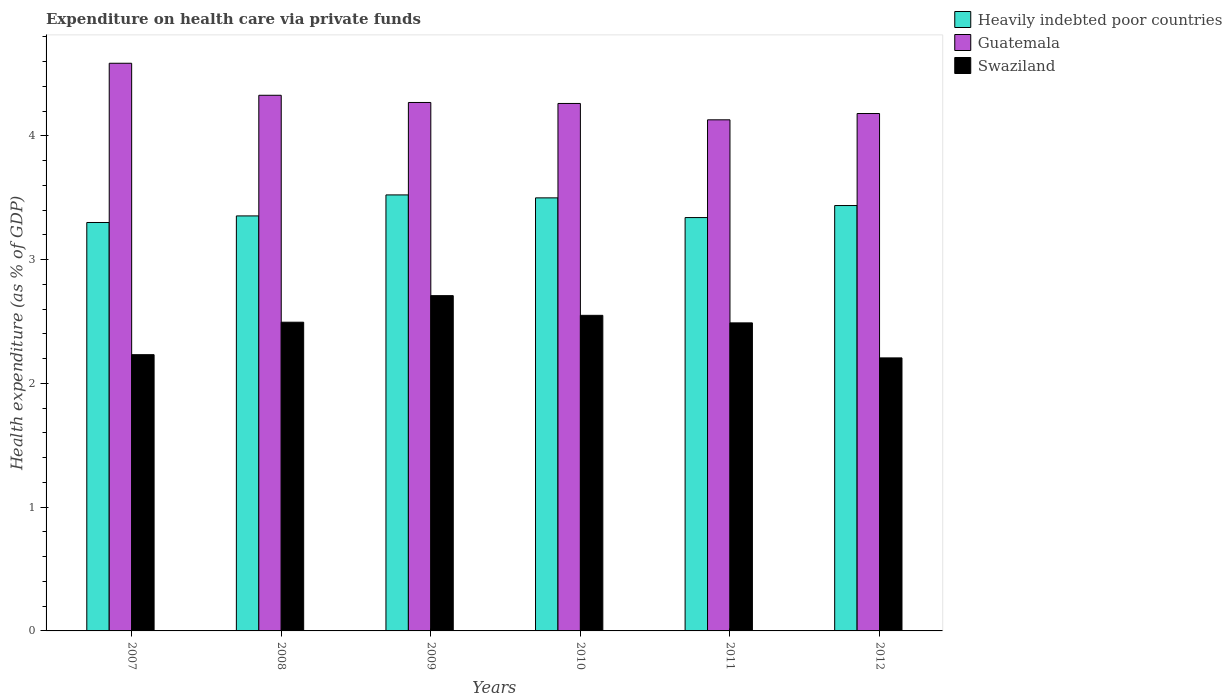How many different coloured bars are there?
Your response must be concise. 3. Are the number of bars per tick equal to the number of legend labels?
Ensure brevity in your answer.  Yes. Are the number of bars on each tick of the X-axis equal?
Provide a succinct answer. Yes. How many bars are there on the 4th tick from the left?
Your response must be concise. 3. In how many cases, is the number of bars for a given year not equal to the number of legend labels?
Make the answer very short. 0. What is the expenditure made on health care in Heavily indebted poor countries in 2008?
Offer a terse response. 3.35. Across all years, what is the maximum expenditure made on health care in Heavily indebted poor countries?
Make the answer very short. 3.52. Across all years, what is the minimum expenditure made on health care in Swaziland?
Give a very brief answer. 2.21. What is the total expenditure made on health care in Heavily indebted poor countries in the graph?
Offer a very short reply. 20.46. What is the difference between the expenditure made on health care in Guatemala in 2008 and that in 2010?
Give a very brief answer. 0.07. What is the difference between the expenditure made on health care in Guatemala in 2011 and the expenditure made on health care in Heavily indebted poor countries in 2008?
Provide a short and direct response. 0.78. What is the average expenditure made on health care in Guatemala per year?
Keep it short and to the point. 4.29. In the year 2007, what is the difference between the expenditure made on health care in Swaziland and expenditure made on health care in Heavily indebted poor countries?
Ensure brevity in your answer.  -1.07. In how many years, is the expenditure made on health care in Swaziland greater than 2.8 %?
Your answer should be compact. 0. What is the ratio of the expenditure made on health care in Swaziland in 2011 to that in 2012?
Your answer should be compact. 1.13. Is the difference between the expenditure made on health care in Swaziland in 2008 and 2011 greater than the difference between the expenditure made on health care in Heavily indebted poor countries in 2008 and 2011?
Ensure brevity in your answer.  No. What is the difference between the highest and the second highest expenditure made on health care in Guatemala?
Provide a short and direct response. 0.26. What is the difference between the highest and the lowest expenditure made on health care in Swaziland?
Your answer should be compact. 0.5. Is the sum of the expenditure made on health care in Swaziland in 2008 and 2010 greater than the maximum expenditure made on health care in Heavily indebted poor countries across all years?
Provide a succinct answer. Yes. What does the 1st bar from the left in 2010 represents?
Offer a very short reply. Heavily indebted poor countries. What does the 2nd bar from the right in 2008 represents?
Your answer should be compact. Guatemala. Is it the case that in every year, the sum of the expenditure made on health care in Heavily indebted poor countries and expenditure made on health care in Guatemala is greater than the expenditure made on health care in Swaziland?
Keep it short and to the point. Yes. How many bars are there?
Keep it short and to the point. 18. Are all the bars in the graph horizontal?
Your response must be concise. No. What is the difference between two consecutive major ticks on the Y-axis?
Keep it short and to the point. 1. Are the values on the major ticks of Y-axis written in scientific E-notation?
Ensure brevity in your answer.  No. Does the graph contain any zero values?
Make the answer very short. No. How many legend labels are there?
Provide a short and direct response. 3. How are the legend labels stacked?
Offer a terse response. Vertical. What is the title of the graph?
Offer a very short reply. Expenditure on health care via private funds. What is the label or title of the Y-axis?
Ensure brevity in your answer.  Health expenditure (as % of GDP). What is the Health expenditure (as % of GDP) of Heavily indebted poor countries in 2007?
Offer a terse response. 3.3. What is the Health expenditure (as % of GDP) of Guatemala in 2007?
Ensure brevity in your answer.  4.59. What is the Health expenditure (as % of GDP) in Swaziland in 2007?
Your answer should be compact. 2.23. What is the Health expenditure (as % of GDP) in Heavily indebted poor countries in 2008?
Offer a very short reply. 3.35. What is the Health expenditure (as % of GDP) in Guatemala in 2008?
Provide a succinct answer. 4.33. What is the Health expenditure (as % of GDP) of Swaziland in 2008?
Provide a short and direct response. 2.49. What is the Health expenditure (as % of GDP) of Heavily indebted poor countries in 2009?
Give a very brief answer. 3.52. What is the Health expenditure (as % of GDP) of Guatemala in 2009?
Your answer should be very brief. 4.27. What is the Health expenditure (as % of GDP) in Swaziland in 2009?
Provide a short and direct response. 2.71. What is the Health expenditure (as % of GDP) of Heavily indebted poor countries in 2010?
Offer a terse response. 3.5. What is the Health expenditure (as % of GDP) in Guatemala in 2010?
Offer a very short reply. 4.26. What is the Health expenditure (as % of GDP) of Swaziland in 2010?
Give a very brief answer. 2.55. What is the Health expenditure (as % of GDP) of Heavily indebted poor countries in 2011?
Your answer should be compact. 3.34. What is the Health expenditure (as % of GDP) of Guatemala in 2011?
Your answer should be compact. 4.13. What is the Health expenditure (as % of GDP) of Swaziland in 2011?
Make the answer very short. 2.49. What is the Health expenditure (as % of GDP) of Heavily indebted poor countries in 2012?
Provide a succinct answer. 3.44. What is the Health expenditure (as % of GDP) in Guatemala in 2012?
Offer a very short reply. 4.18. What is the Health expenditure (as % of GDP) of Swaziland in 2012?
Offer a very short reply. 2.21. Across all years, what is the maximum Health expenditure (as % of GDP) of Heavily indebted poor countries?
Offer a very short reply. 3.52. Across all years, what is the maximum Health expenditure (as % of GDP) in Guatemala?
Ensure brevity in your answer.  4.59. Across all years, what is the maximum Health expenditure (as % of GDP) in Swaziland?
Your answer should be very brief. 2.71. Across all years, what is the minimum Health expenditure (as % of GDP) of Heavily indebted poor countries?
Your answer should be compact. 3.3. Across all years, what is the minimum Health expenditure (as % of GDP) in Guatemala?
Provide a succinct answer. 4.13. Across all years, what is the minimum Health expenditure (as % of GDP) of Swaziland?
Give a very brief answer. 2.21. What is the total Health expenditure (as % of GDP) in Heavily indebted poor countries in the graph?
Offer a very short reply. 20.46. What is the total Health expenditure (as % of GDP) in Guatemala in the graph?
Provide a succinct answer. 25.76. What is the total Health expenditure (as % of GDP) of Swaziland in the graph?
Provide a short and direct response. 14.68. What is the difference between the Health expenditure (as % of GDP) of Heavily indebted poor countries in 2007 and that in 2008?
Offer a terse response. -0.05. What is the difference between the Health expenditure (as % of GDP) of Guatemala in 2007 and that in 2008?
Give a very brief answer. 0.26. What is the difference between the Health expenditure (as % of GDP) of Swaziland in 2007 and that in 2008?
Give a very brief answer. -0.26. What is the difference between the Health expenditure (as % of GDP) in Heavily indebted poor countries in 2007 and that in 2009?
Provide a short and direct response. -0.22. What is the difference between the Health expenditure (as % of GDP) of Guatemala in 2007 and that in 2009?
Your answer should be compact. 0.32. What is the difference between the Health expenditure (as % of GDP) of Swaziland in 2007 and that in 2009?
Provide a succinct answer. -0.48. What is the difference between the Health expenditure (as % of GDP) in Heavily indebted poor countries in 2007 and that in 2010?
Your response must be concise. -0.2. What is the difference between the Health expenditure (as % of GDP) of Guatemala in 2007 and that in 2010?
Ensure brevity in your answer.  0.32. What is the difference between the Health expenditure (as % of GDP) of Swaziland in 2007 and that in 2010?
Make the answer very short. -0.32. What is the difference between the Health expenditure (as % of GDP) of Heavily indebted poor countries in 2007 and that in 2011?
Provide a succinct answer. -0.04. What is the difference between the Health expenditure (as % of GDP) of Guatemala in 2007 and that in 2011?
Give a very brief answer. 0.46. What is the difference between the Health expenditure (as % of GDP) of Swaziland in 2007 and that in 2011?
Ensure brevity in your answer.  -0.26. What is the difference between the Health expenditure (as % of GDP) of Heavily indebted poor countries in 2007 and that in 2012?
Ensure brevity in your answer.  -0.14. What is the difference between the Health expenditure (as % of GDP) in Guatemala in 2007 and that in 2012?
Ensure brevity in your answer.  0.41. What is the difference between the Health expenditure (as % of GDP) of Swaziland in 2007 and that in 2012?
Give a very brief answer. 0.03. What is the difference between the Health expenditure (as % of GDP) of Heavily indebted poor countries in 2008 and that in 2009?
Ensure brevity in your answer.  -0.17. What is the difference between the Health expenditure (as % of GDP) in Guatemala in 2008 and that in 2009?
Provide a short and direct response. 0.06. What is the difference between the Health expenditure (as % of GDP) in Swaziland in 2008 and that in 2009?
Provide a short and direct response. -0.21. What is the difference between the Health expenditure (as % of GDP) in Heavily indebted poor countries in 2008 and that in 2010?
Provide a short and direct response. -0.15. What is the difference between the Health expenditure (as % of GDP) of Guatemala in 2008 and that in 2010?
Ensure brevity in your answer.  0.07. What is the difference between the Health expenditure (as % of GDP) in Swaziland in 2008 and that in 2010?
Give a very brief answer. -0.06. What is the difference between the Health expenditure (as % of GDP) of Heavily indebted poor countries in 2008 and that in 2011?
Give a very brief answer. 0.01. What is the difference between the Health expenditure (as % of GDP) of Guatemala in 2008 and that in 2011?
Offer a terse response. 0.2. What is the difference between the Health expenditure (as % of GDP) of Swaziland in 2008 and that in 2011?
Your answer should be very brief. 0.01. What is the difference between the Health expenditure (as % of GDP) in Heavily indebted poor countries in 2008 and that in 2012?
Give a very brief answer. -0.08. What is the difference between the Health expenditure (as % of GDP) of Guatemala in 2008 and that in 2012?
Give a very brief answer. 0.15. What is the difference between the Health expenditure (as % of GDP) in Swaziland in 2008 and that in 2012?
Your answer should be compact. 0.29. What is the difference between the Health expenditure (as % of GDP) of Heavily indebted poor countries in 2009 and that in 2010?
Your answer should be compact. 0.02. What is the difference between the Health expenditure (as % of GDP) of Guatemala in 2009 and that in 2010?
Provide a succinct answer. 0.01. What is the difference between the Health expenditure (as % of GDP) in Swaziland in 2009 and that in 2010?
Offer a very short reply. 0.16. What is the difference between the Health expenditure (as % of GDP) in Heavily indebted poor countries in 2009 and that in 2011?
Make the answer very short. 0.18. What is the difference between the Health expenditure (as % of GDP) in Guatemala in 2009 and that in 2011?
Keep it short and to the point. 0.14. What is the difference between the Health expenditure (as % of GDP) in Swaziland in 2009 and that in 2011?
Your answer should be very brief. 0.22. What is the difference between the Health expenditure (as % of GDP) in Heavily indebted poor countries in 2009 and that in 2012?
Keep it short and to the point. 0.09. What is the difference between the Health expenditure (as % of GDP) in Guatemala in 2009 and that in 2012?
Provide a short and direct response. 0.09. What is the difference between the Health expenditure (as % of GDP) in Swaziland in 2009 and that in 2012?
Your answer should be compact. 0.5. What is the difference between the Health expenditure (as % of GDP) of Heavily indebted poor countries in 2010 and that in 2011?
Ensure brevity in your answer.  0.16. What is the difference between the Health expenditure (as % of GDP) in Guatemala in 2010 and that in 2011?
Make the answer very short. 0.13. What is the difference between the Health expenditure (as % of GDP) in Swaziland in 2010 and that in 2011?
Your answer should be compact. 0.06. What is the difference between the Health expenditure (as % of GDP) in Heavily indebted poor countries in 2010 and that in 2012?
Ensure brevity in your answer.  0.06. What is the difference between the Health expenditure (as % of GDP) in Guatemala in 2010 and that in 2012?
Give a very brief answer. 0.08. What is the difference between the Health expenditure (as % of GDP) in Swaziland in 2010 and that in 2012?
Give a very brief answer. 0.34. What is the difference between the Health expenditure (as % of GDP) of Heavily indebted poor countries in 2011 and that in 2012?
Your answer should be compact. -0.1. What is the difference between the Health expenditure (as % of GDP) of Guatemala in 2011 and that in 2012?
Offer a very short reply. -0.05. What is the difference between the Health expenditure (as % of GDP) in Swaziland in 2011 and that in 2012?
Your answer should be compact. 0.28. What is the difference between the Health expenditure (as % of GDP) of Heavily indebted poor countries in 2007 and the Health expenditure (as % of GDP) of Guatemala in 2008?
Give a very brief answer. -1.03. What is the difference between the Health expenditure (as % of GDP) in Heavily indebted poor countries in 2007 and the Health expenditure (as % of GDP) in Swaziland in 2008?
Offer a terse response. 0.81. What is the difference between the Health expenditure (as % of GDP) in Guatemala in 2007 and the Health expenditure (as % of GDP) in Swaziland in 2008?
Your answer should be compact. 2.09. What is the difference between the Health expenditure (as % of GDP) in Heavily indebted poor countries in 2007 and the Health expenditure (as % of GDP) in Guatemala in 2009?
Your answer should be very brief. -0.97. What is the difference between the Health expenditure (as % of GDP) of Heavily indebted poor countries in 2007 and the Health expenditure (as % of GDP) of Swaziland in 2009?
Provide a short and direct response. 0.59. What is the difference between the Health expenditure (as % of GDP) in Guatemala in 2007 and the Health expenditure (as % of GDP) in Swaziland in 2009?
Give a very brief answer. 1.88. What is the difference between the Health expenditure (as % of GDP) in Heavily indebted poor countries in 2007 and the Health expenditure (as % of GDP) in Guatemala in 2010?
Your answer should be compact. -0.96. What is the difference between the Health expenditure (as % of GDP) in Heavily indebted poor countries in 2007 and the Health expenditure (as % of GDP) in Swaziland in 2010?
Offer a terse response. 0.75. What is the difference between the Health expenditure (as % of GDP) in Guatemala in 2007 and the Health expenditure (as % of GDP) in Swaziland in 2010?
Provide a succinct answer. 2.04. What is the difference between the Health expenditure (as % of GDP) in Heavily indebted poor countries in 2007 and the Health expenditure (as % of GDP) in Guatemala in 2011?
Provide a succinct answer. -0.83. What is the difference between the Health expenditure (as % of GDP) in Heavily indebted poor countries in 2007 and the Health expenditure (as % of GDP) in Swaziland in 2011?
Ensure brevity in your answer.  0.81. What is the difference between the Health expenditure (as % of GDP) of Guatemala in 2007 and the Health expenditure (as % of GDP) of Swaziland in 2011?
Your response must be concise. 2.1. What is the difference between the Health expenditure (as % of GDP) in Heavily indebted poor countries in 2007 and the Health expenditure (as % of GDP) in Guatemala in 2012?
Offer a very short reply. -0.88. What is the difference between the Health expenditure (as % of GDP) of Heavily indebted poor countries in 2007 and the Health expenditure (as % of GDP) of Swaziland in 2012?
Offer a terse response. 1.09. What is the difference between the Health expenditure (as % of GDP) in Guatemala in 2007 and the Health expenditure (as % of GDP) in Swaziland in 2012?
Provide a short and direct response. 2.38. What is the difference between the Health expenditure (as % of GDP) in Heavily indebted poor countries in 2008 and the Health expenditure (as % of GDP) in Guatemala in 2009?
Keep it short and to the point. -0.92. What is the difference between the Health expenditure (as % of GDP) of Heavily indebted poor countries in 2008 and the Health expenditure (as % of GDP) of Swaziland in 2009?
Your answer should be compact. 0.64. What is the difference between the Health expenditure (as % of GDP) of Guatemala in 2008 and the Health expenditure (as % of GDP) of Swaziland in 2009?
Make the answer very short. 1.62. What is the difference between the Health expenditure (as % of GDP) of Heavily indebted poor countries in 2008 and the Health expenditure (as % of GDP) of Guatemala in 2010?
Provide a short and direct response. -0.91. What is the difference between the Health expenditure (as % of GDP) in Heavily indebted poor countries in 2008 and the Health expenditure (as % of GDP) in Swaziland in 2010?
Your answer should be compact. 0.8. What is the difference between the Health expenditure (as % of GDP) in Guatemala in 2008 and the Health expenditure (as % of GDP) in Swaziland in 2010?
Provide a short and direct response. 1.78. What is the difference between the Health expenditure (as % of GDP) in Heavily indebted poor countries in 2008 and the Health expenditure (as % of GDP) in Guatemala in 2011?
Ensure brevity in your answer.  -0.78. What is the difference between the Health expenditure (as % of GDP) of Heavily indebted poor countries in 2008 and the Health expenditure (as % of GDP) of Swaziland in 2011?
Your response must be concise. 0.86. What is the difference between the Health expenditure (as % of GDP) in Guatemala in 2008 and the Health expenditure (as % of GDP) in Swaziland in 2011?
Provide a short and direct response. 1.84. What is the difference between the Health expenditure (as % of GDP) of Heavily indebted poor countries in 2008 and the Health expenditure (as % of GDP) of Guatemala in 2012?
Provide a succinct answer. -0.83. What is the difference between the Health expenditure (as % of GDP) of Heavily indebted poor countries in 2008 and the Health expenditure (as % of GDP) of Swaziland in 2012?
Provide a succinct answer. 1.15. What is the difference between the Health expenditure (as % of GDP) of Guatemala in 2008 and the Health expenditure (as % of GDP) of Swaziland in 2012?
Your response must be concise. 2.12. What is the difference between the Health expenditure (as % of GDP) in Heavily indebted poor countries in 2009 and the Health expenditure (as % of GDP) in Guatemala in 2010?
Offer a very short reply. -0.74. What is the difference between the Health expenditure (as % of GDP) in Heavily indebted poor countries in 2009 and the Health expenditure (as % of GDP) in Swaziland in 2010?
Offer a very short reply. 0.97. What is the difference between the Health expenditure (as % of GDP) of Guatemala in 2009 and the Health expenditure (as % of GDP) of Swaziland in 2010?
Provide a short and direct response. 1.72. What is the difference between the Health expenditure (as % of GDP) of Heavily indebted poor countries in 2009 and the Health expenditure (as % of GDP) of Guatemala in 2011?
Your response must be concise. -0.61. What is the difference between the Health expenditure (as % of GDP) in Heavily indebted poor countries in 2009 and the Health expenditure (as % of GDP) in Swaziland in 2011?
Keep it short and to the point. 1.03. What is the difference between the Health expenditure (as % of GDP) in Guatemala in 2009 and the Health expenditure (as % of GDP) in Swaziland in 2011?
Offer a very short reply. 1.78. What is the difference between the Health expenditure (as % of GDP) in Heavily indebted poor countries in 2009 and the Health expenditure (as % of GDP) in Guatemala in 2012?
Provide a short and direct response. -0.66. What is the difference between the Health expenditure (as % of GDP) in Heavily indebted poor countries in 2009 and the Health expenditure (as % of GDP) in Swaziland in 2012?
Offer a very short reply. 1.32. What is the difference between the Health expenditure (as % of GDP) of Guatemala in 2009 and the Health expenditure (as % of GDP) of Swaziland in 2012?
Your answer should be compact. 2.06. What is the difference between the Health expenditure (as % of GDP) of Heavily indebted poor countries in 2010 and the Health expenditure (as % of GDP) of Guatemala in 2011?
Offer a very short reply. -0.63. What is the difference between the Health expenditure (as % of GDP) in Heavily indebted poor countries in 2010 and the Health expenditure (as % of GDP) in Swaziland in 2011?
Provide a succinct answer. 1.01. What is the difference between the Health expenditure (as % of GDP) of Guatemala in 2010 and the Health expenditure (as % of GDP) of Swaziland in 2011?
Your response must be concise. 1.77. What is the difference between the Health expenditure (as % of GDP) of Heavily indebted poor countries in 2010 and the Health expenditure (as % of GDP) of Guatemala in 2012?
Give a very brief answer. -0.68. What is the difference between the Health expenditure (as % of GDP) in Heavily indebted poor countries in 2010 and the Health expenditure (as % of GDP) in Swaziland in 2012?
Provide a succinct answer. 1.29. What is the difference between the Health expenditure (as % of GDP) in Guatemala in 2010 and the Health expenditure (as % of GDP) in Swaziland in 2012?
Your answer should be compact. 2.06. What is the difference between the Health expenditure (as % of GDP) in Heavily indebted poor countries in 2011 and the Health expenditure (as % of GDP) in Guatemala in 2012?
Offer a very short reply. -0.84. What is the difference between the Health expenditure (as % of GDP) of Heavily indebted poor countries in 2011 and the Health expenditure (as % of GDP) of Swaziland in 2012?
Give a very brief answer. 1.13. What is the difference between the Health expenditure (as % of GDP) in Guatemala in 2011 and the Health expenditure (as % of GDP) in Swaziland in 2012?
Your answer should be very brief. 1.92. What is the average Health expenditure (as % of GDP) in Heavily indebted poor countries per year?
Offer a very short reply. 3.41. What is the average Health expenditure (as % of GDP) of Guatemala per year?
Provide a short and direct response. 4.29. What is the average Health expenditure (as % of GDP) in Swaziland per year?
Your answer should be compact. 2.45. In the year 2007, what is the difference between the Health expenditure (as % of GDP) in Heavily indebted poor countries and Health expenditure (as % of GDP) in Guatemala?
Give a very brief answer. -1.29. In the year 2007, what is the difference between the Health expenditure (as % of GDP) in Heavily indebted poor countries and Health expenditure (as % of GDP) in Swaziland?
Make the answer very short. 1.07. In the year 2007, what is the difference between the Health expenditure (as % of GDP) of Guatemala and Health expenditure (as % of GDP) of Swaziland?
Give a very brief answer. 2.36. In the year 2008, what is the difference between the Health expenditure (as % of GDP) in Heavily indebted poor countries and Health expenditure (as % of GDP) in Guatemala?
Provide a succinct answer. -0.97. In the year 2008, what is the difference between the Health expenditure (as % of GDP) of Heavily indebted poor countries and Health expenditure (as % of GDP) of Swaziland?
Give a very brief answer. 0.86. In the year 2008, what is the difference between the Health expenditure (as % of GDP) of Guatemala and Health expenditure (as % of GDP) of Swaziland?
Make the answer very short. 1.83. In the year 2009, what is the difference between the Health expenditure (as % of GDP) of Heavily indebted poor countries and Health expenditure (as % of GDP) of Guatemala?
Your answer should be very brief. -0.75. In the year 2009, what is the difference between the Health expenditure (as % of GDP) in Heavily indebted poor countries and Health expenditure (as % of GDP) in Swaziland?
Your answer should be very brief. 0.81. In the year 2009, what is the difference between the Health expenditure (as % of GDP) in Guatemala and Health expenditure (as % of GDP) in Swaziland?
Provide a short and direct response. 1.56. In the year 2010, what is the difference between the Health expenditure (as % of GDP) of Heavily indebted poor countries and Health expenditure (as % of GDP) of Guatemala?
Your answer should be compact. -0.76. In the year 2010, what is the difference between the Health expenditure (as % of GDP) of Heavily indebted poor countries and Health expenditure (as % of GDP) of Swaziland?
Give a very brief answer. 0.95. In the year 2010, what is the difference between the Health expenditure (as % of GDP) of Guatemala and Health expenditure (as % of GDP) of Swaziland?
Your answer should be compact. 1.71. In the year 2011, what is the difference between the Health expenditure (as % of GDP) of Heavily indebted poor countries and Health expenditure (as % of GDP) of Guatemala?
Your response must be concise. -0.79. In the year 2011, what is the difference between the Health expenditure (as % of GDP) of Heavily indebted poor countries and Health expenditure (as % of GDP) of Swaziland?
Your answer should be very brief. 0.85. In the year 2011, what is the difference between the Health expenditure (as % of GDP) in Guatemala and Health expenditure (as % of GDP) in Swaziland?
Your answer should be compact. 1.64. In the year 2012, what is the difference between the Health expenditure (as % of GDP) of Heavily indebted poor countries and Health expenditure (as % of GDP) of Guatemala?
Make the answer very short. -0.74. In the year 2012, what is the difference between the Health expenditure (as % of GDP) of Heavily indebted poor countries and Health expenditure (as % of GDP) of Swaziland?
Offer a very short reply. 1.23. In the year 2012, what is the difference between the Health expenditure (as % of GDP) in Guatemala and Health expenditure (as % of GDP) in Swaziland?
Keep it short and to the point. 1.98. What is the ratio of the Health expenditure (as % of GDP) in Heavily indebted poor countries in 2007 to that in 2008?
Ensure brevity in your answer.  0.98. What is the ratio of the Health expenditure (as % of GDP) in Guatemala in 2007 to that in 2008?
Your answer should be very brief. 1.06. What is the ratio of the Health expenditure (as % of GDP) in Swaziland in 2007 to that in 2008?
Offer a very short reply. 0.89. What is the ratio of the Health expenditure (as % of GDP) in Heavily indebted poor countries in 2007 to that in 2009?
Offer a terse response. 0.94. What is the ratio of the Health expenditure (as % of GDP) of Guatemala in 2007 to that in 2009?
Your answer should be compact. 1.07. What is the ratio of the Health expenditure (as % of GDP) in Swaziland in 2007 to that in 2009?
Ensure brevity in your answer.  0.82. What is the ratio of the Health expenditure (as % of GDP) in Heavily indebted poor countries in 2007 to that in 2010?
Provide a succinct answer. 0.94. What is the ratio of the Health expenditure (as % of GDP) in Guatemala in 2007 to that in 2010?
Your answer should be compact. 1.08. What is the ratio of the Health expenditure (as % of GDP) in Swaziland in 2007 to that in 2010?
Keep it short and to the point. 0.88. What is the ratio of the Health expenditure (as % of GDP) in Heavily indebted poor countries in 2007 to that in 2011?
Your response must be concise. 0.99. What is the ratio of the Health expenditure (as % of GDP) of Guatemala in 2007 to that in 2011?
Provide a succinct answer. 1.11. What is the ratio of the Health expenditure (as % of GDP) of Swaziland in 2007 to that in 2011?
Give a very brief answer. 0.9. What is the ratio of the Health expenditure (as % of GDP) of Heavily indebted poor countries in 2007 to that in 2012?
Provide a short and direct response. 0.96. What is the ratio of the Health expenditure (as % of GDP) of Guatemala in 2007 to that in 2012?
Your answer should be very brief. 1.1. What is the ratio of the Health expenditure (as % of GDP) in Swaziland in 2007 to that in 2012?
Your answer should be compact. 1.01. What is the ratio of the Health expenditure (as % of GDP) in Heavily indebted poor countries in 2008 to that in 2009?
Your response must be concise. 0.95. What is the ratio of the Health expenditure (as % of GDP) in Guatemala in 2008 to that in 2009?
Your answer should be compact. 1.01. What is the ratio of the Health expenditure (as % of GDP) in Swaziland in 2008 to that in 2009?
Offer a terse response. 0.92. What is the ratio of the Health expenditure (as % of GDP) of Guatemala in 2008 to that in 2010?
Give a very brief answer. 1.02. What is the ratio of the Health expenditure (as % of GDP) in Swaziland in 2008 to that in 2010?
Your answer should be very brief. 0.98. What is the ratio of the Health expenditure (as % of GDP) of Heavily indebted poor countries in 2008 to that in 2011?
Give a very brief answer. 1. What is the ratio of the Health expenditure (as % of GDP) in Guatemala in 2008 to that in 2011?
Your response must be concise. 1.05. What is the ratio of the Health expenditure (as % of GDP) in Swaziland in 2008 to that in 2011?
Provide a short and direct response. 1. What is the ratio of the Health expenditure (as % of GDP) of Heavily indebted poor countries in 2008 to that in 2012?
Give a very brief answer. 0.98. What is the ratio of the Health expenditure (as % of GDP) in Guatemala in 2008 to that in 2012?
Provide a short and direct response. 1.04. What is the ratio of the Health expenditure (as % of GDP) in Swaziland in 2008 to that in 2012?
Your answer should be compact. 1.13. What is the ratio of the Health expenditure (as % of GDP) of Heavily indebted poor countries in 2009 to that in 2010?
Keep it short and to the point. 1.01. What is the ratio of the Health expenditure (as % of GDP) in Guatemala in 2009 to that in 2010?
Provide a short and direct response. 1. What is the ratio of the Health expenditure (as % of GDP) in Swaziland in 2009 to that in 2010?
Your answer should be compact. 1.06. What is the ratio of the Health expenditure (as % of GDP) in Heavily indebted poor countries in 2009 to that in 2011?
Provide a succinct answer. 1.05. What is the ratio of the Health expenditure (as % of GDP) of Guatemala in 2009 to that in 2011?
Offer a terse response. 1.03. What is the ratio of the Health expenditure (as % of GDP) of Swaziland in 2009 to that in 2011?
Your answer should be very brief. 1.09. What is the ratio of the Health expenditure (as % of GDP) of Guatemala in 2009 to that in 2012?
Offer a terse response. 1.02. What is the ratio of the Health expenditure (as % of GDP) in Swaziland in 2009 to that in 2012?
Your answer should be very brief. 1.23. What is the ratio of the Health expenditure (as % of GDP) in Heavily indebted poor countries in 2010 to that in 2011?
Provide a succinct answer. 1.05. What is the ratio of the Health expenditure (as % of GDP) of Guatemala in 2010 to that in 2011?
Your answer should be compact. 1.03. What is the ratio of the Health expenditure (as % of GDP) in Swaziland in 2010 to that in 2011?
Your response must be concise. 1.02. What is the ratio of the Health expenditure (as % of GDP) of Guatemala in 2010 to that in 2012?
Keep it short and to the point. 1.02. What is the ratio of the Health expenditure (as % of GDP) in Swaziland in 2010 to that in 2012?
Provide a succinct answer. 1.16. What is the ratio of the Health expenditure (as % of GDP) of Heavily indebted poor countries in 2011 to that in 2012?
Offer a very short reply. 0.97. What is the ratio of the Health expenditure (as % of GDP) of Swaziland in 2011 to that in 2012?
Your answer should be compact. 1.13. What is the difference between the highest and the second highest Health expenditure (as % of GDP) in Heavily indebted poor countries?
Keep it short and to the point. 0.02. What is the difference between the highest and the second highest Health expenditure (as % of GDP) of Guatemala?
Make the answer very short. 0.26. What is the difference between the highest and the second highest Health expenditure (as % of GDP) in Swaziland?
Provide a succinct answer. 0.16. What is the difference between the highest and the lowest Health expenditure (as % of GDP) in Heavily indebted poor countries?
Provide a short and direct response. 0.22. What is the difference between the highest and the lowest Health expenditure (as % of GDP) in Guatemala?
Provide a short and direct response. 0.46. What is the difference between the highest and the lowest Health expenditure (as % of GDP) in Swaziland?
Give a very brief answer. 0.5. 